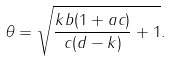<formula> <loc_0><loc_0><loc_500><loc_500>\theta = \sqrt { \frac { k b ( 1 + a c ) } { c ( d - k ) } + 1 } .</formula> 